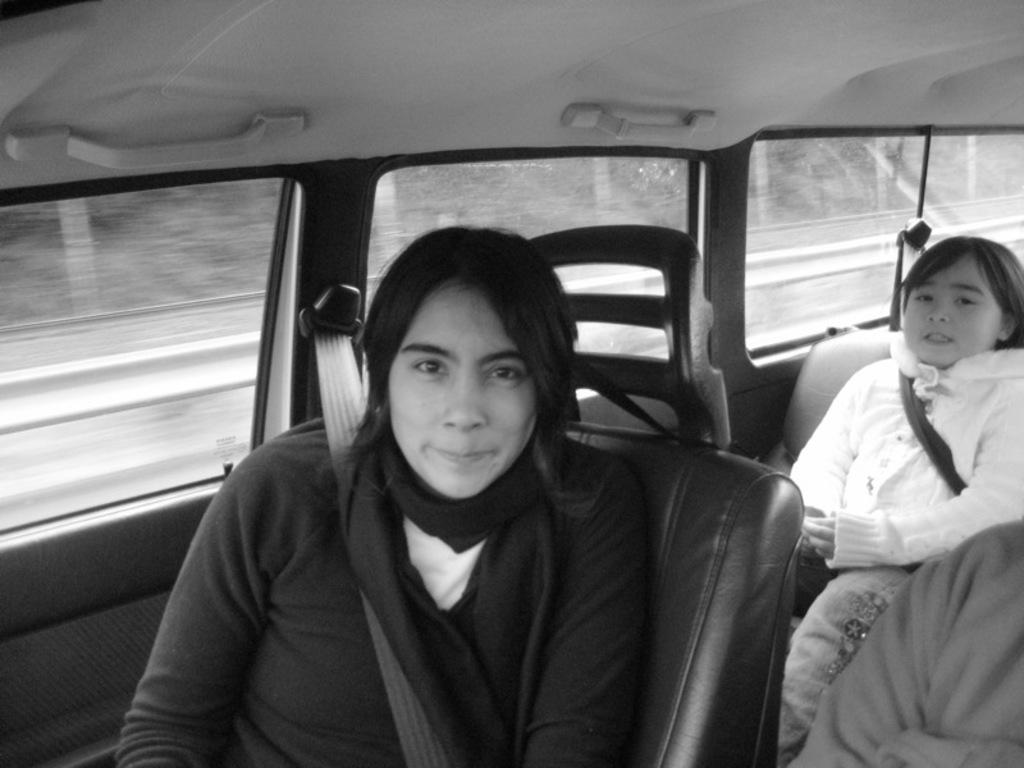Who is present in the image? There is a woman and a girl in the image. What is the woman doing in the image? The woman is sitting on a seat and wearing a seat belt. What is the woman's expression in the image? The woman is smiling in the image. What is the girl doing in the image? The girl is sitting on a seat. Where are the woman and the girl located in the image? Both the woman and the girl are in a vehicle. What type of quiver can be seen hanging on the wall in the image? There is no quiver present in the image; it features a woman and a girl sitting in a vehicle. What kind of ornament is the girl holding in the image? There is no ornament visible in the image; the girl is simply sitting on a seat. 